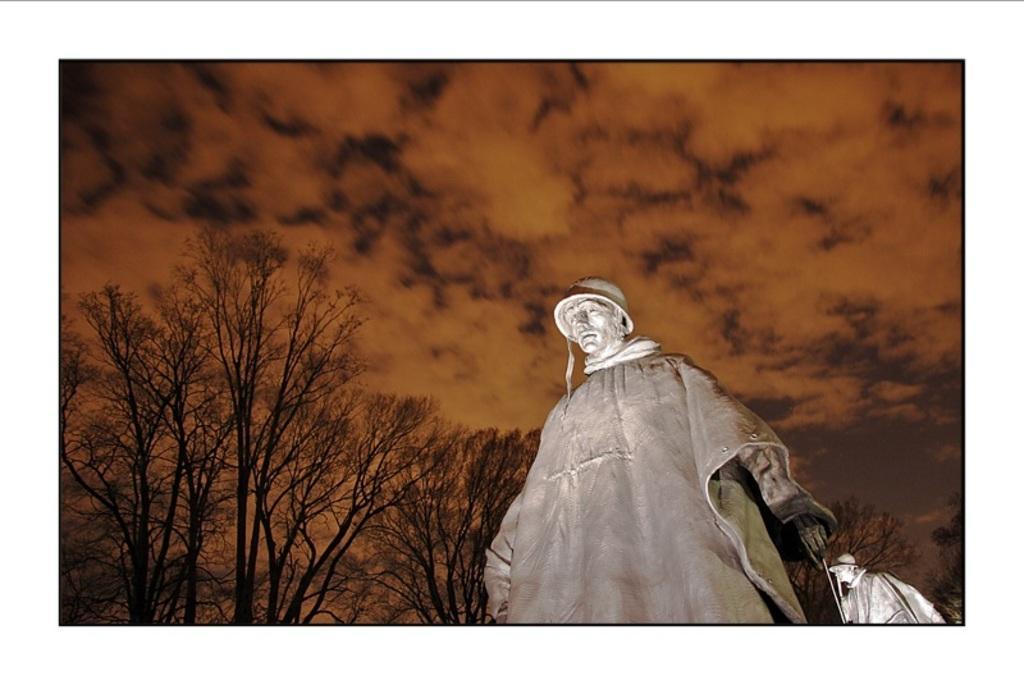Can you describe this image briefly? In this image we can see two statues, some big trees and the background there is the cloudy sky. 